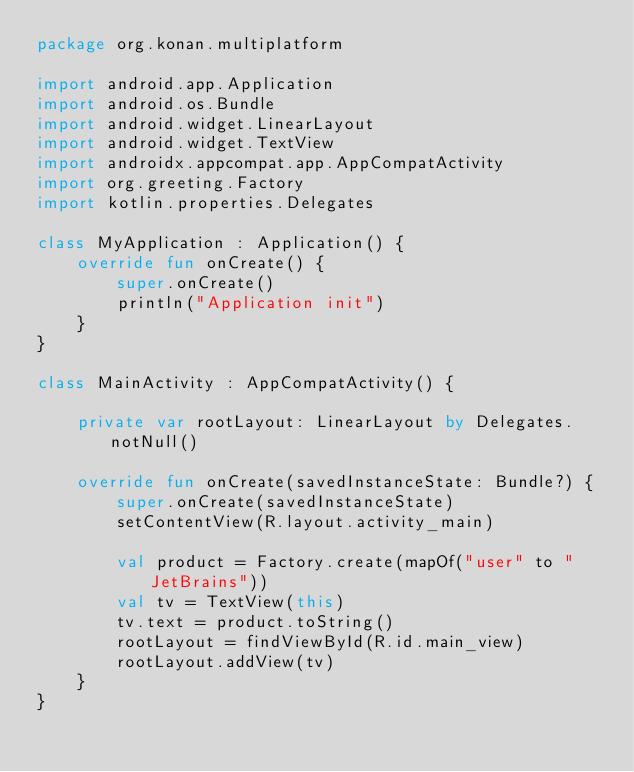Convert code to text. <code><loc_0><loc_0><loc_500><loc_500><_Kotlin_>package org.konan.multiplatform

import android.app.Application
import android.os.Bundle
import android.widget.LinearLayout
import android.widget.TextView
import androidx.appcompat.app.AppCompatActivity
import org.greeting.Factory
import kotlin.properties.Delegates

class MyApplication : Application() {
    override fun onCreate() {
        super.onCreate()
        println("Application init")
    }
}

class MainActivity : AppCompatActivity() {

    private var rootLayout: LinearLayout by Delegates.notNull()

    override fun onCreate(savedInstanceState: Bundle?) {
        super.onCreate(savedInstanceState)
        setContentView(R.layout.activity_main)

        val product = Factory.create(mapOf("user" to "JetBrains"))
        val tv = TextView(this)
        tv.text = product.toString()
        rootLayout = findViewById(R.id.main_view)
        rootLayout.addView(tv)
    }
}</code> 